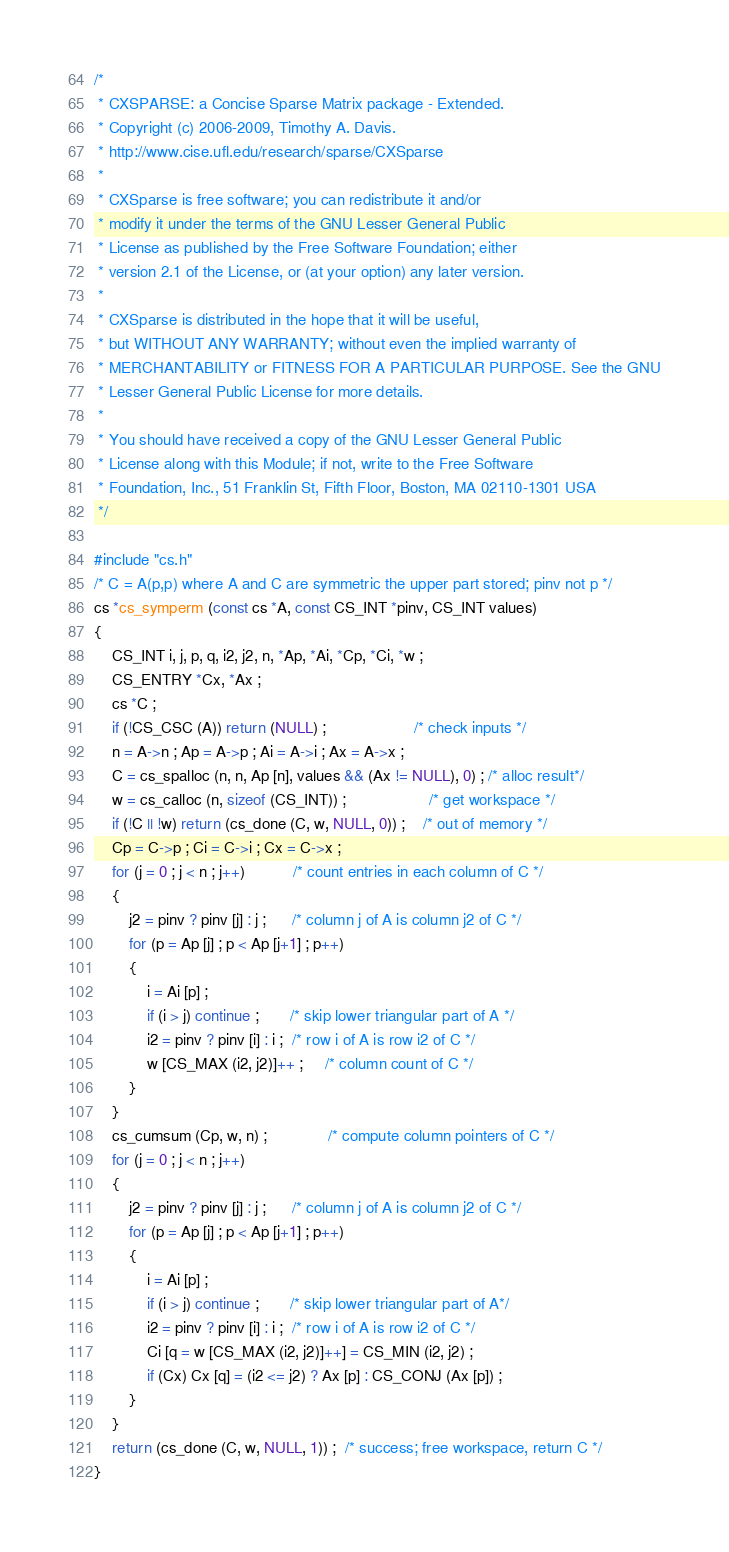<code> <loc_0><loc_0><loc_500><loc_500><_C_>/*
 * CXSPARSE: a Concise Sparse Matrix package - Extended.
 * Copyright (c) 2006-2009, Timothy A. Davis.
 * http://www.cise.ufl.edu/research/sparse/CXSparse
 * 
 * CXSparse is free software; you can redistribute it and/or
 * modify it under the terms of the GNU Lesser General Public
 * License as published by the Free Software Foundation; either
 * version 2.1 of the License, or (at your option) any later version.
 * 
 * CXSparse is distributed in the hope that it will be useful,
 * but WITHOUT ANY WARRANTY; without even the implied warranty of
 * MERCHANTABILITY or FITNESS FOR A PARTICULAR PURPOSE. See the GNU
 * Lesser General Public License for more details.
 * 
 * You should have received a copy of the GNU Lesser General Public
 * License along with this Module; if not, write to the Free Software
 * Foundation, Inc., 51 Franklin St, Fifth Floor, Boston, MA 02110-1301 USA
 */

#include "cs.h"
/* C = A(p,p) where A and C are symmetric the upper part stored; pinv not p */
cs *cs_symperm (const cs *A, const CS_INT *pinv, CS_INT values)
{
    CS_INT i, j, p, q, i2, j2, n, *Ap, *Ai, *Cp, *Ci, *w ;
    CS_ENTRY *Cx, *Ax ;
    cs *C ;
    if (!CS_CSC (A)) return (NULL) ;                    /* check inputs */
    n = A->n ; Ap = A->p ; Ai = A->i ; Ax = A->x ;
    C = cs_spalloc (n, n, Ap [n], values && (Ax != NULL), 0) ; /* alloc result*/
    w = cs_calloc (n, sizeof (CS_INT)) ;                   /* get workspace */
    if (!C || !w) return (cs_done (C, w, NULL, 0)) ;    /* out of memory */
    Cp = C->p ; Ci = C->i ; Cx = C->x ;
    for (j = 0 ; j < n ; j++)           /* count entries in each column of C */
    {
        j2 = pinv ? pinv [j] : j ;      /* column j of A is column j2 of C */
        for (p = Ap [j] ; p < Ap [j+1] ; p++)
        {
            i = Ai [p] ;
            if (i > j) continue ;       /* skip lower triangular part of A */
            i2 = pinv ? pinv [i] : i ;  /* row i of A is row i2 of C */
            w [CS_MAX (i2, j2)]++ ;     /* column count of C */
        }
    }
    cs_cumsum (Cp, w, n) ;              /* compute column pointers of C */
    for (j = 0 ; j < n ; j++)
    {
        j2 = pinv ? pinv [j] : j ;      /* column j of A is column j2 of C */
        for (p = Ap [j] ; p < Ap [j+1] ; p++)
        {
            i = Ai [p] ;
            if (i > j) continue ;       /* skip lower triangular part of A*/
            i2 = pinv ? pinv [i] : i ;  /* row i of A is row i2 of C */
            Ci [q = w [CS_MAX (i2, j2)]++] = CS_MIN (i2, j2) ;
            if (Cx) Cx [q] = (i2 <= j2) ? Ax [p] : CS_CONJ (Ax [p]) ;
        }
    }
    return (cs_done (C, w, NULL, 1)) ;  /* success; free workspace, return C */
}
</code> 